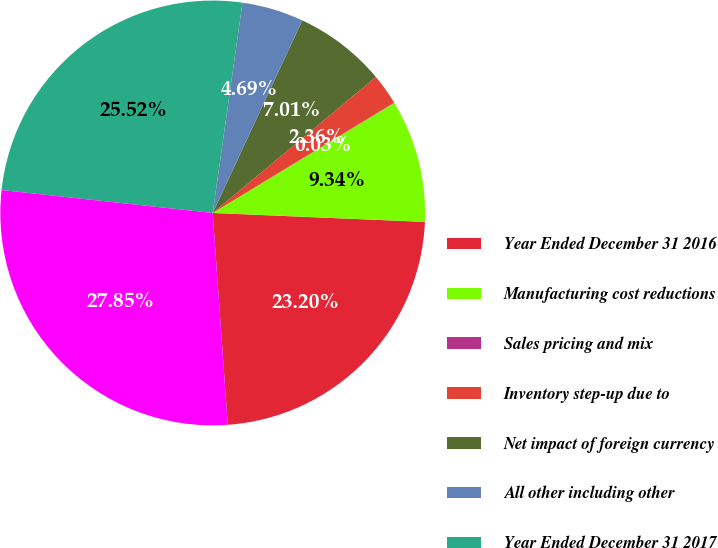<chart> <loc_0><loc_0><loc_500><loc_500><pie_chart><fcel>Year Ended December 31 2016<fcel>Manufacturing cost reductions<fcel>Sales pricing and mix<fcel>Inventory step-up due to<fcel>Net impact of foreign currency<fcel>All other including other<fcel>Year Ended December 31 2017<fcel>Year Ended December 31 2018<nl><fcel>23.2%<fcel>9.34%<fcel>0.03%<fcel>2.36%<fcel>7.01%<fcel>4.69%<fcel>25.52%<fcel>27.85%<nl></chart> 